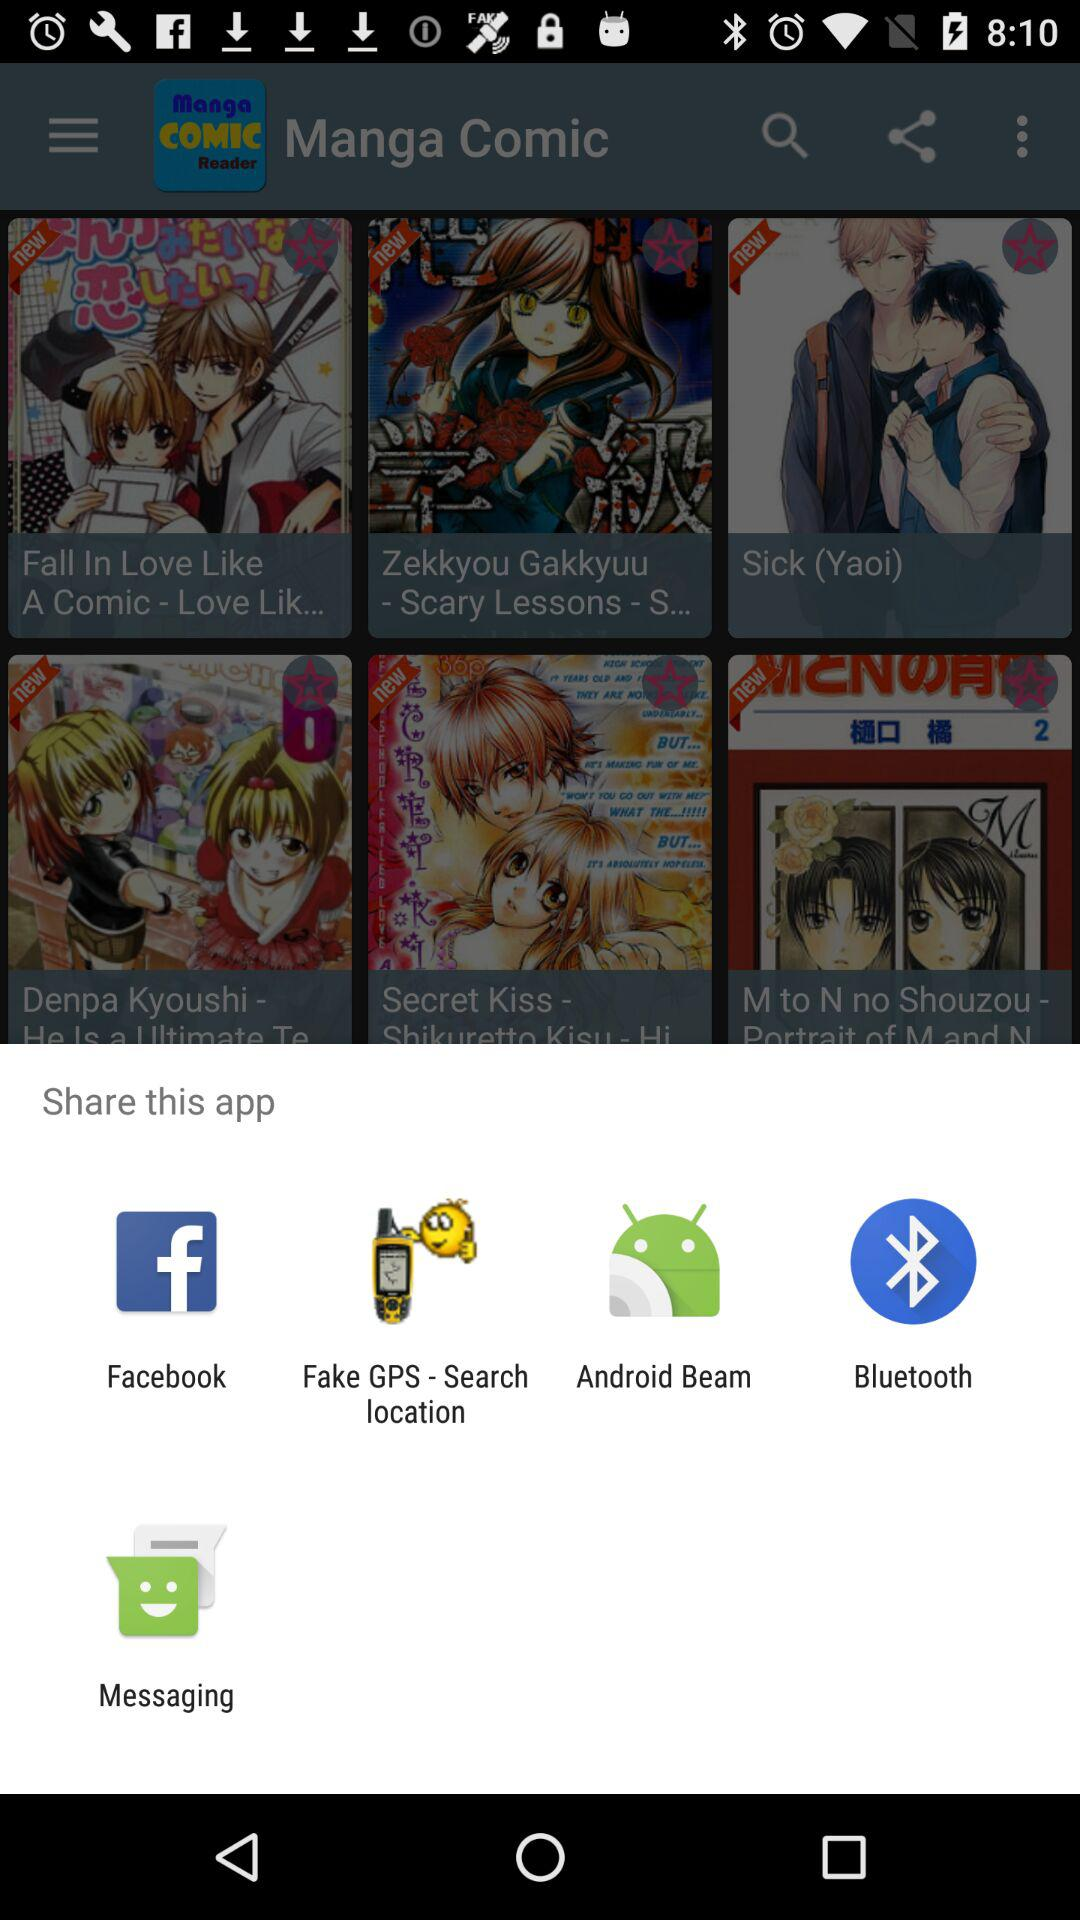What options are given to share? The options given to share are : "Facebook", "Fake GPS - Search location", "Android Beam", "Bluetooth" and "Messaging". 